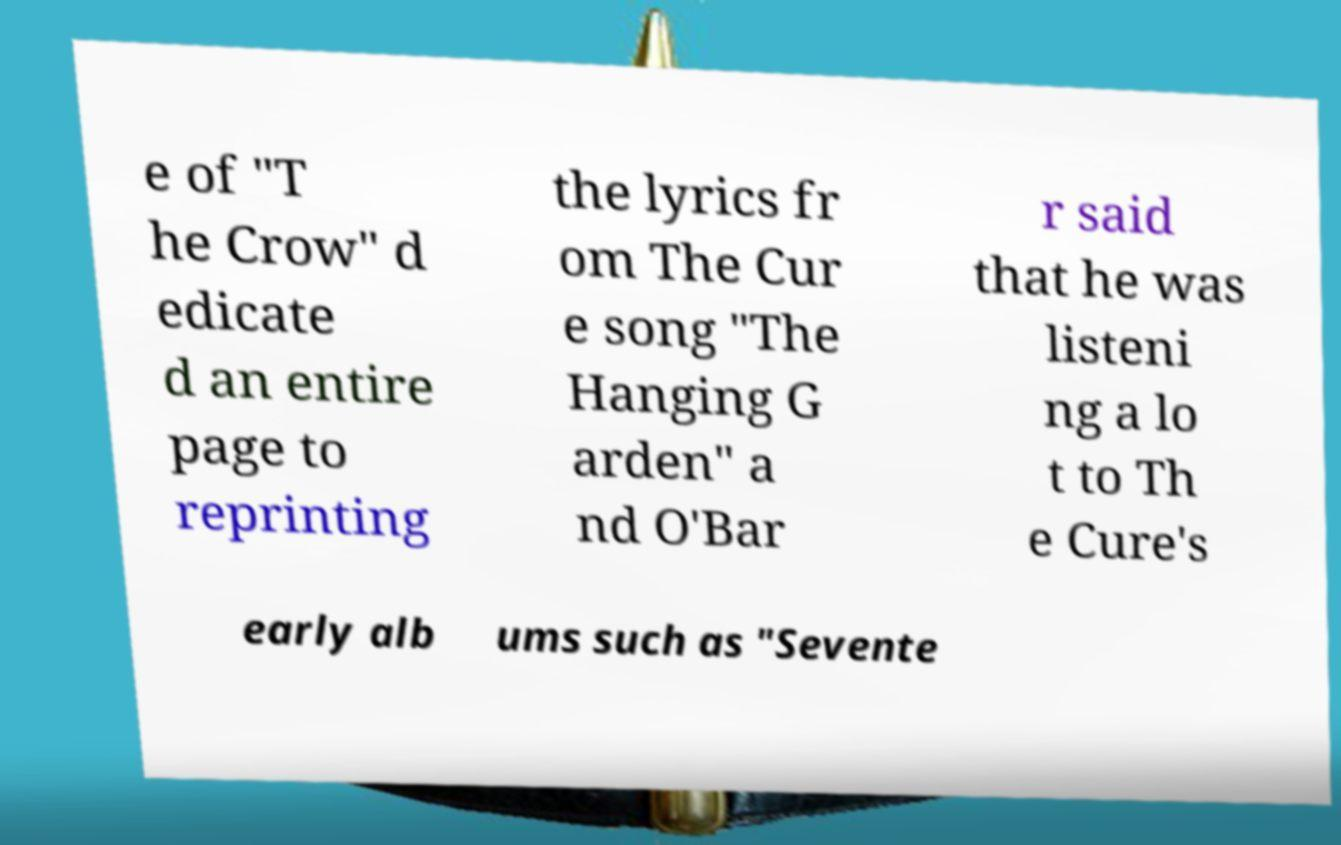Please read and relay the text visible in this image. What does it say? e of "T he Crow" d edicate d an entire page to reprinting the lyrics fr om The Cur e song "The Hanging G arden" a nd O'Bar r said that he was listeni ng a lo t to Th e Cure's early alb ums such as "Sevente 